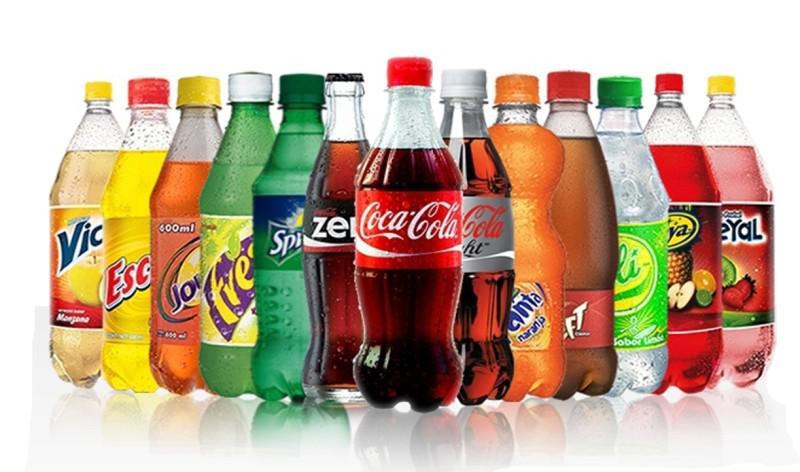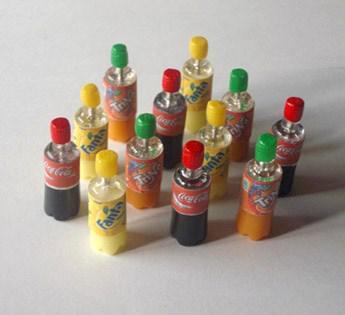The first image is the image on the left, the second image is the image on the right. Analyze the images presented: Is the assertion "In one of the images there are only bottles of drinks." valid? Answer yes or no. Yes. The first image is the image on the left, the second image is the image on the right. Assess this claim about the two images: "The left image contains at least three cans of soda.". Correct or not? Answer yes or no. No. 